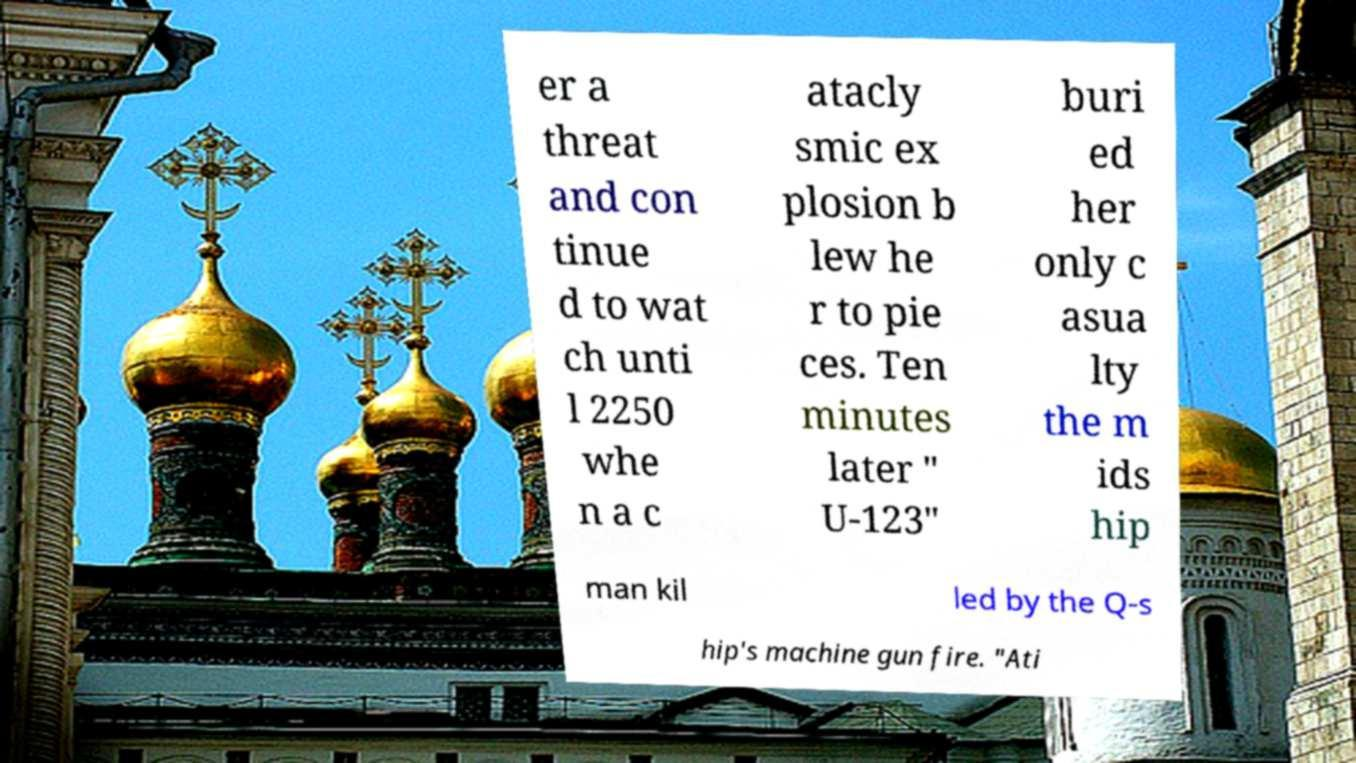Can you accurately transcribe the text from the provided image for me? er a threat and con tinue d to wat ch unti l 2250 whe n a c atacly smic ex plosion b lew he r to pie ces. Ten minutes later " U-123" buri ed her only c asua lty the m ids hip man kil led by the Q-s hip's machine gun fire. "Ati 